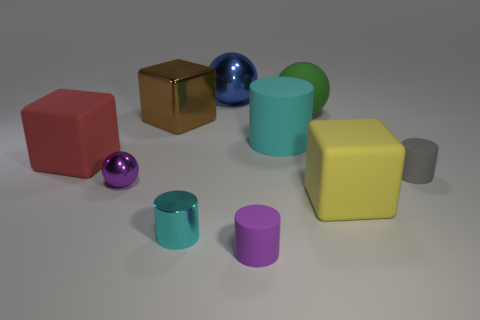Subtract all brown cylinders. Subtract all brown spheres. How many cylinders are left? 4 Subtract all spheres. How many objects are left? 7 Add 7 tiny green matte cylinders. How many tiny green matte cylinders exist? 7 Subtract 0 red spheres. How many objects are left? 10 Subtract all metal objects. Subtract all tiny purple balls. How many objects are left? 5 Add 6 gray rubber objects. How many gray rubber objects are left? 7 